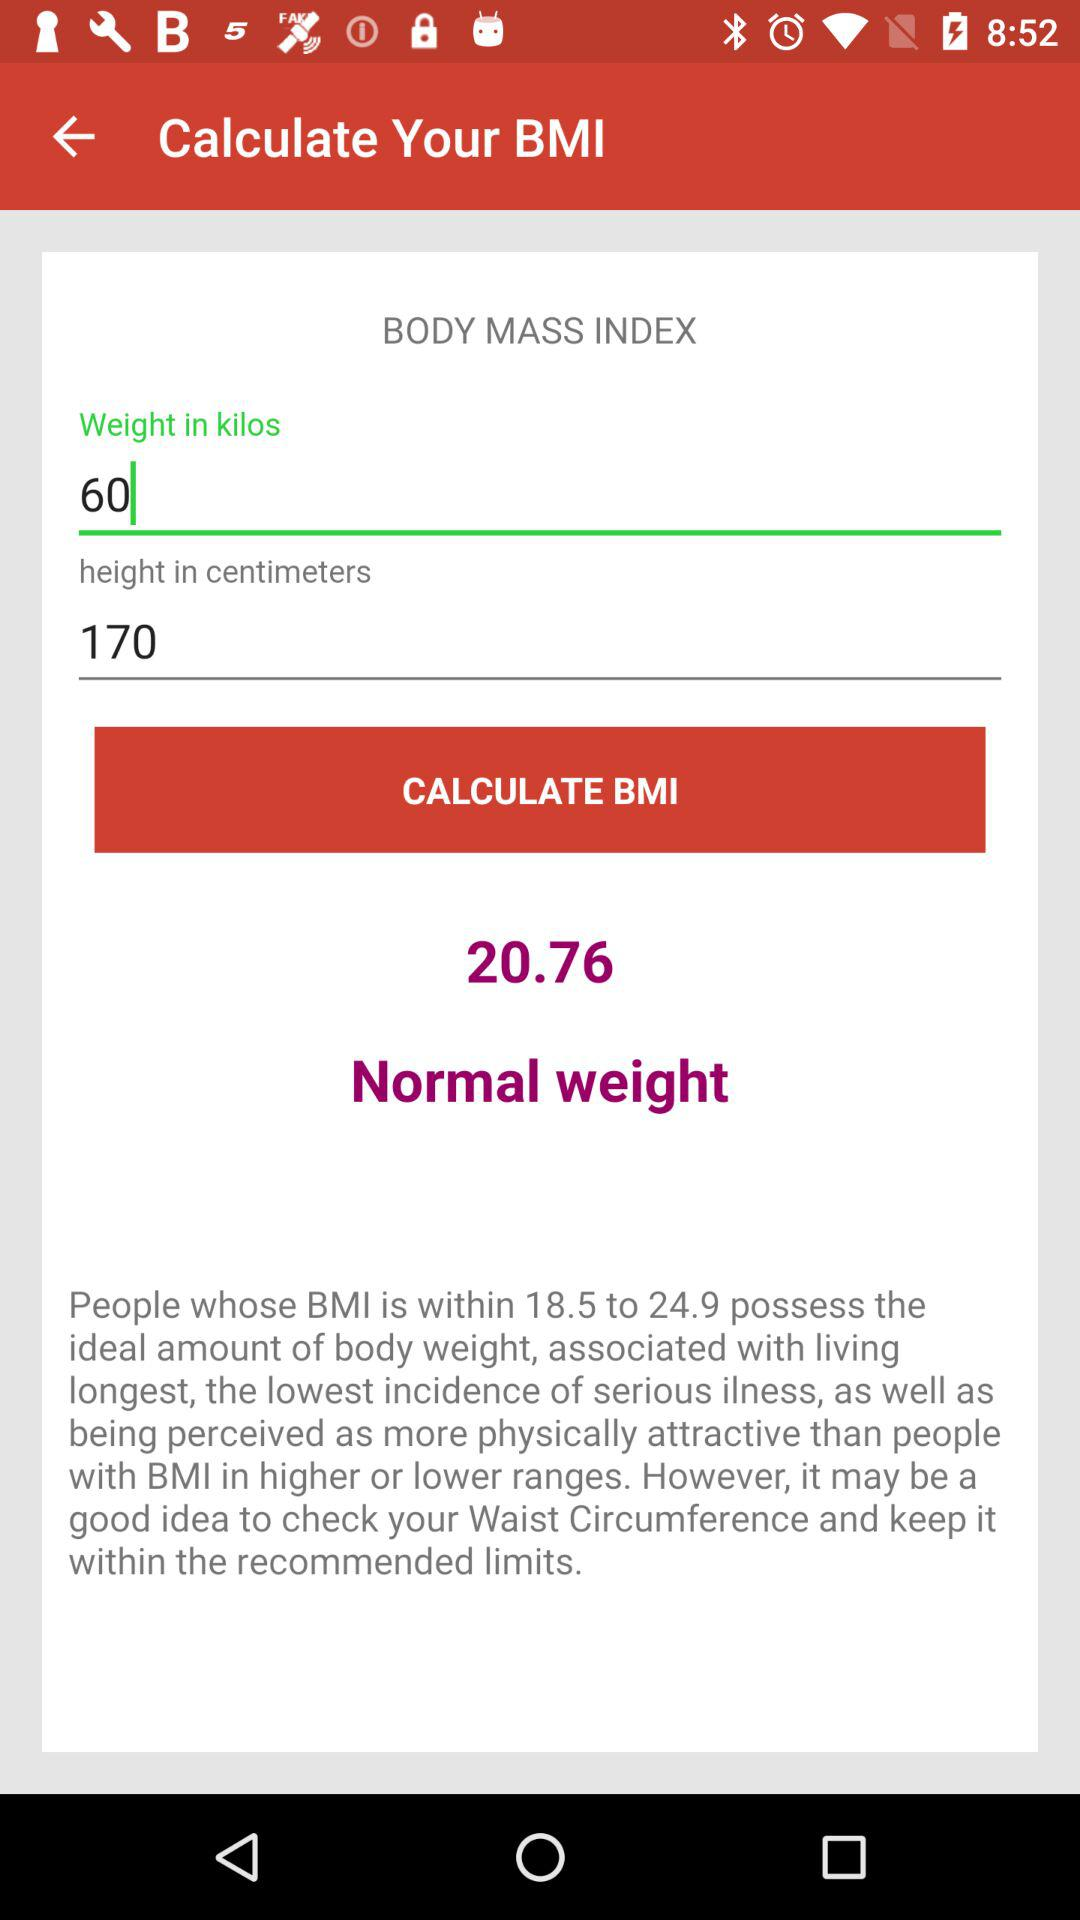What is the unit of weight? The unit of weight is kilos. 